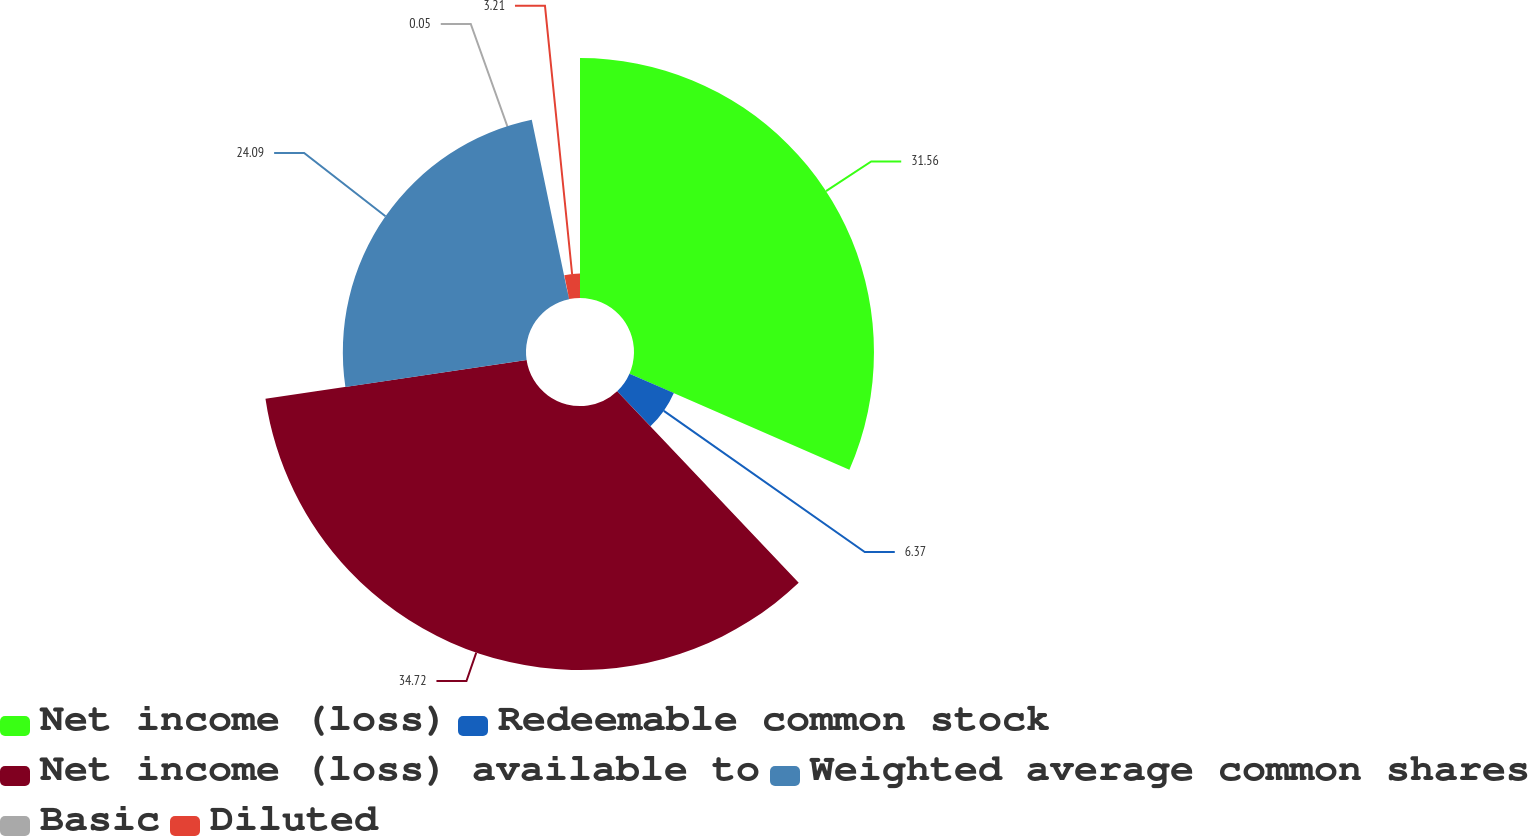Convert chart. <chart><loc_0><loc_0><loc_500><loc_500><pie_chart><fcel>Net income (loss)<fcel>Redeemable common stock<fcel>Net income (loss) available to<fcel>Weighted average common shares<fcel>Basic<fcel>Diluted<nl><fcel>31.56%<fcel>6.37%<fcel>34.72%<fcel>24.09%<fcel>0.05%<fcel>3.21%<nl></chart> 